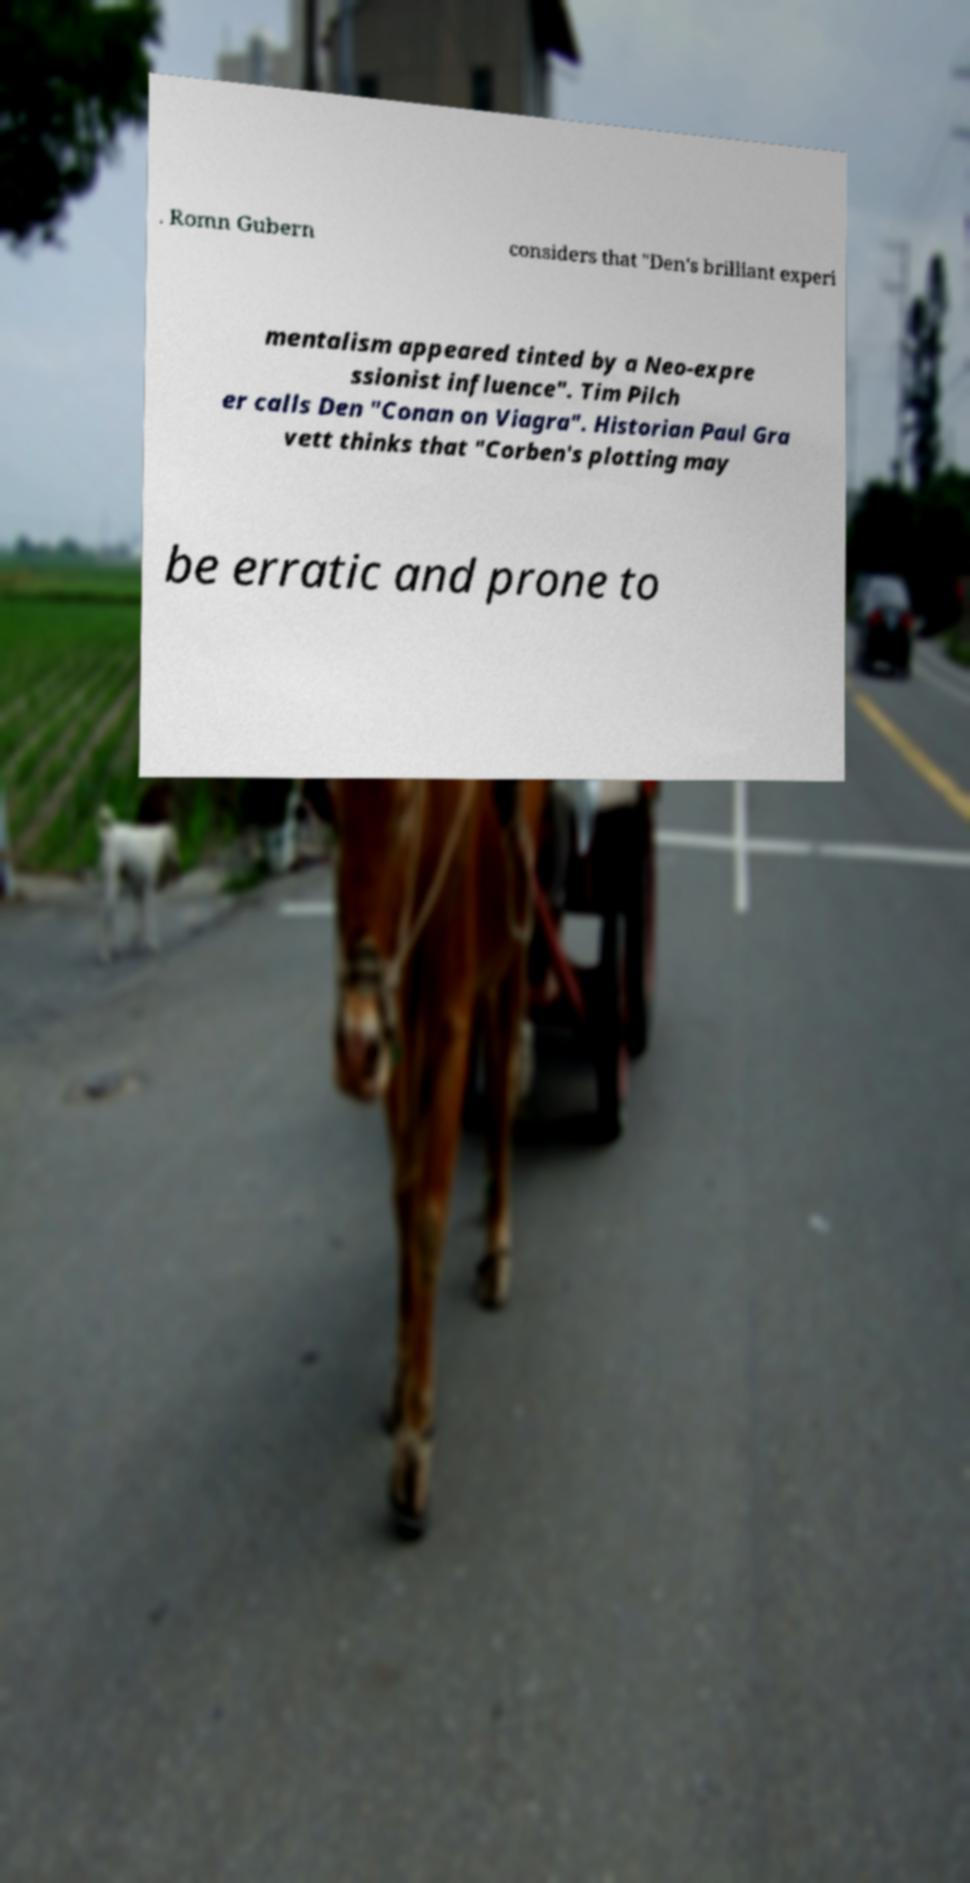Please read and relay the text visible in this image. What does it say? . Romn Gubern considers that "Den's brilliant experi mentalism appeared tinted by a Neo-expre ssionist influence". Tim Pilch er calls Den "Conan on Viagra". Historian Paul Gra vett thinks that "Corben's plotting may be erratic and prone to 